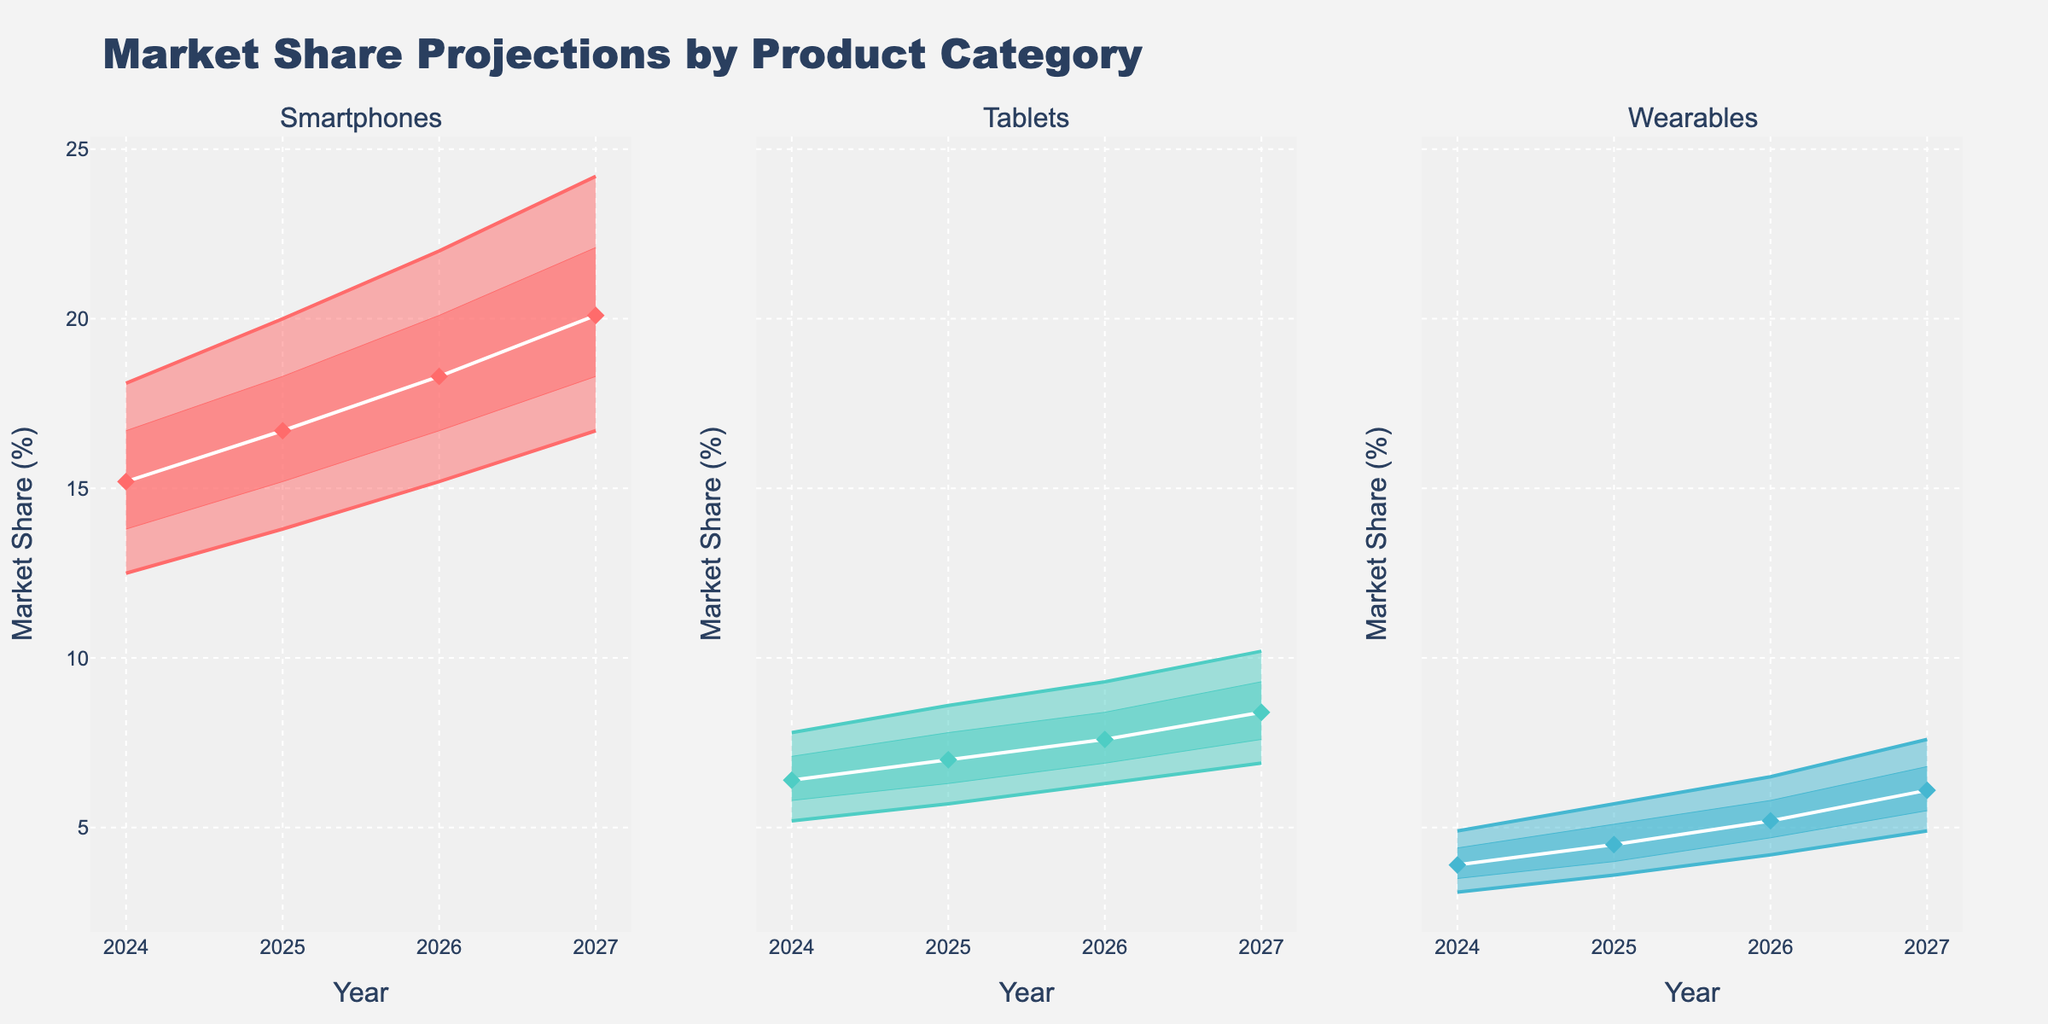What is the title of the figure? The title is usually displayed at the top of the figure, indicating what the figure represents. Here, it is positioned center-top of the figure.
Answer: Market Share Projections by Product Category Which product category is projected to have the highest median market share in 2025? To determine the highest median market share in 2025, look at the P50 (median) values for each category.
Answer: Smartphones What does the y-axis represent? The y-axis is labeled to indicate what is being measured. Here, it specifies the measurement unit used across all subplots.
Answer: Market Share (%) How does the P90 value for Wearables change from 2024 to 2027? Look at the P90 values for Wearables from 2024 to 2027. Note the changes in these values year by year. The P90 value increases each year.
Answer: It increases from 4.9 to 7.6 In 2027, which product category has the widest range between the P10 and P90 values? Calculate the difference between the P10 and P90 values for each category in 2027, and identify the category with the largest difference.
Answer: Smartphones What is the central tendency value of the market share for Tablets in 2026? The central tendency for Tablets in 2026 is represented by the P50 (median) value.
Answer: 7.6 Which product category shows the least increase in market share from 2024 to 2027 based on the median value? Compare the median (P50) values for each category over the given years, focusing on the increase from 2024 to 2027, and identify the smallest increase.
Answer: Wearables How does the interquartile range (IQR) for Smartphones change from 2025 to 2027? The IQR is the difference between P75 and P25. Calculate the difference for Smartphones in 2025 and 2027, then compare these values.
Answer: It increases from 3.1 to 3.8 Which year shows the highest variability in market share projections for Tablets? Variability can be assessed by the range (difference between P10 and P90). Calculate the range for each year and identify the highest.
Answer: 2027 How does the expected growth trajectory for Wearables compare to that of Tablets? Compare the trend lines for the median (P50) market share values for Wearables and Tablets over the given years. Wearables have a slower growth rate compared to Tablets.
Answer: Wearables grow slower 